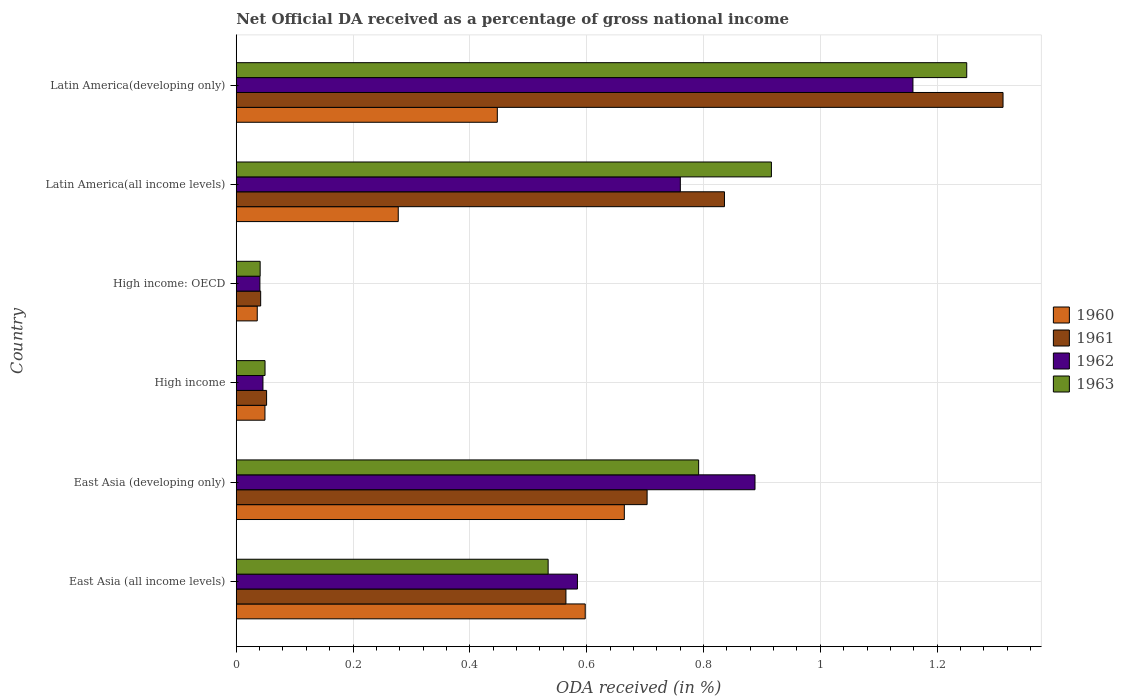How many different coloured bars are there?
Provide a succinct answer. 4. How many groups of bars are there?
Keep it short and to the point. 6. Are the number of bars on each tick of the Y-axis equal?
Offer a terse response. Yes. How many bars are there on the 3rd tick from the top?
Ensure brevity in your answer.  4. How many bars are there on the 4th tick from the bottom?
Keep it short and to the point. 4. What is the label of the 3rd group of bars from the top?
Provide a succinct answer. High income: OECD. What is the net official DA received in 1960 in High income: OECD?
Provide a short and direct response. 0.04. Across all countries, what is the maximum net official DA received in 1961?
Give a very brief answer. 1.31. Across all countries, what is the minimum net official DA received in 1961?
Provide a short and direct response. 0.04. In which country was the net official DA received in 1960 maximum?
Make the answer very short. East Asia (developing only). In which country was the net official DA received in 1961 minimum?
Your answer should be very brief. High income: OECD. What is the total net official DA received in 1962 in the graph?
Provide a short and direct response. 3.48. What is the difference between the net official DA received in 1962 in High income: OECD and that in Latin America(all income levels)?
Your response must be concise. -0.72. What is the difference between the net official DA received in 1960 in Latin America(developing only) and the net official DA received in 1962 in High income: OECD?
Ensure brevity in your answer.  0.41. What is the average net official DA received in 1962 per country?
Give a very brief answer. 0.58. What is the difference between the net official DA received in 1960 and net official DA received in 1961 in East Asia (all income levels)?
Keep it short and to the point. 0.03. In how many countries, is the net official DA received in 1960 greater than 1.12 %?
Make the answer very short. 0. What is the ratio of the net official DA received in 1961 in Latin America(all income levels) to that in Latin America(developing only)?
Make the answer very short. 0.64. Is the net official DA received in 1963 in East Asia (developing only) less than that in Latin America(developing only)?
Your response must be concise. Yes. What is the difference between the highest and the second highest net official DA received in 1961?
Your response must be concise. 0.48. What is the difference between the highest and the lowest net official DA received in 1961?
Provide a short and direct response. 1.27. In how many countries, is the net official DA received in 1962 greater than the average net official DA received in 1962 taken over all countries?
Provide a succinct answer. 4. Is it the case that in every country, the sum of the net official DA received in 1961 and net official DA received in 1962 is greater than the sum of net official DA received in 1963 and net official DA received in 1960?
Give a very brief answer. No. What does the 3rd bar from the top in East Asia (all income levels) represents?
Offer a very short reply. 1961. What does the 2nd bar from the bottom in Latin America(all income levels) represents?
Offer a terse response. 1961. How many bars are there?
Keep it short and to the point. 24. Are the values on the major ticks of X-axis written in scientific E-notation?
Offer a terse response. No. Where does the legend appear in the graph?
Provide a short and direct response. Center right. How many legend labels are there?
Offer a terse response. 4. What is the title of the graph?
Provide a succinct answer. Net Official DA received as a percentage of gross national income. What is the label or title of the X-axis?
Offer a very short reply. ODA received (in %). What is the label or title of the Y-axis?
Your answer should be compact. Country. What is the ODA received (in %) of 1960 in East Asia (all income levels)?
Provide a short and direct response. 0.6. What is the ODA received (in %) in 1961 in East Asia (all income levels)?
Make the answer very short. 0.56. What is the ODA received (in %) of 1962 in East Asia (all income levels)?
Provide a succinct answer. 0.58. What is the ODA received (in %) of 1963 in East Asia (all income levels)?
Your answer should be very brief. 0.53. What is the ODA received (in %) of 1960 in East Asia (developing only)?
Your answer should be very brief. 0.66. What is the ODA received (in %) of 1961 in East Asia (developing only)?
Your response must be concise. 0.7. What is the ODA received (in %) of 1962 in East Asia (developing only)?
Your response must be concise. 0.89. What is the ODA received (in %) in 1963 in East Asia (developing only)?
Ensure brevity in your answer.  0.79. What is the ODA received (in %) of 1960 in High income?
Your answer should be compact. 0.05. What is the ODA received (in %) of 1961 in High income?
Provide a short and direct response. 0.05. What is the ODA received (in %) in 1962 in High income?
Keep it short and to the point. 0.05. What is the ODA received (in %) in 1963 in High income?
Provide a succinct answer. 0.05. What is the ODA received (in %) in 1960 in High income: OECD?
Offer a very short reply. 0.04. What is the ODA received (in %) in 1961 in High income: OECD?
Keep it short and to the point. 0.04. What is the ODA received (in %) in 1962 in High income: OECD?
Make the answer very short. 0.04. What is the ODA received (in %) in 1963 in High income: OECD?
Keep it short and to the point. 0.04. What is the ODA received (in %) in 1960 in Latin America(all income levels)?
Offer a very short reply. 0.28. What is the ODA received (in %) of 1961 in Latin America(all income levels)?
Keep it short and to the point. 0.84. What is the ODA received (in %) of 1962 in Latin America(all income levels)?
Provide a succinct answer. 0.76. What is the ODA received (in %) of 1963 in Latin America(all income levels)?
Your answer should be very brief. 0.92. What is the ODA received (in %) of 1960 in Latin America(developing only)?
Provide a short and direct response. 0.45. What is the ODA received (in %) in 1961 in Latin America(developing only)?
Your answer should be very brief. 1.31. What is the ODA received (in %) in 1962 in Latin America(developing only)?
Keep it short and to the point. 1.16. What is the ODA received (in %) of 1963 in Latin America(developing only)?
Provide a short and direct response. 1.25. Across all countries, what is the maximum ODA received (in %) of 1960?
Provide a succinct answer. 0.66. Across all countries, what is the maximum ODA received (in %) of 1961?
Your response must be concise. 1.31. Across all countries, what is the maximum ODA received (in %) in 1962?
Give a very brief answer. 1.16. Across all countries, what is the maximum ODA received (in %) in 1963?
Keep it short and to the point. 1.25. Across all countries, what is the minimum ODA received (in %) in 1960?
Offer a very short reply. 0.04. Across all countries, what is the minimum ODA received (in %) of 1961?
Give a very brief answer. 0.04. Across all countries, what is the minimum ODA received (in %) of 1962?
Ensure brevity in your answer.  0.04. Across all countries, what is the minimum ODA received (in %) of 1963?
Make the answer very short. 0.04. What is the total ODA received (in %) of 1960 in the graph?
Your answer should be very brief. 2.07. What is the total ODA received (in %) of 1961 in the graph?
Give a very brief answer. 3.51. What is the total ODA received (in %) in 1962 in the graph?
Ensure brevity in your answer.  3.48. What is the total ODA received (in %) of 1963 in the graph?
Ensure brevity in your answer.  3.58. What is the difference between the ODA received (in %) of 1960 in East Asia (all income levels) and that in East Asia (developing only)?
Ensure brevity in your answer.  -0.07. What is the difference between the ODA received (in %) in 1961 in East Asia (all income levels) and that in East Asia (developing only)?
Give a very brief answer. -0.14. What is the difference between the ODA received (in %) of 1962 in East Asia (all income levels) and that in East Asia (developing only)?
Keep it short and to the point. -0.3. What is the difference between the ODA received (in %) of 1963 in East Asia (all income levels) and that in East Asia (developing only)?
Keep it short and to the point. -0.26. What is the difference between the ODA received (in %) of 1960 in East Asia (all income levels) and that in High income?
Provide a short and direct response. 0.55. What is the difference between the ODA received (in %) in 1961 in East Asia (all income levels) and that in High income?
Ensure brevity in your answer.  0.51. What is the difference between the ODA received (in %) of 1962 in East Asia (all income levels) and that in High income?
Ensure brevity in your answer.  0.54. What is the difference between the ODA received (in %) of 1963 in East Asia (all income levels) and that in High income?
Give a very brief answer. 0.48. What is the difference between the ODA received (in %) of 1960 in East Asia (all income levels) and that in High income: OECD?
Provide a short and direct response. 0.56. What is the difference between the ODA received (in %) of 1961 in East Asia (all income levels) and that in High income: OECD?
Make the answer very short. 0.52. What is the difference between the ODA received (in %) in 1962 in East Asia (all income levels) and that in High income: OECD?
Ensure brevity in your answer.  0.54. What is the difference between the ODA received (in %) in 1963 in East Asia (all income levels) and that in High income: OECD?
Offer a very short reply. 0.49. What is the difference between the ODA received (in %) of 1960 in East Asia (all income levels) and that in Latin America(all income levels)?
Your response must be concise. 0.32. What is the difference between the ODA received (in %) in 1961 in East Asia (all income levels) and that in Latin America(all income levels)?
Provide a succinct answer. -0.27. What is the difference between the ODA received (in %) in 1962 in East Asia (all income levels) and that in Latin America(all income levels)?
Provide a short and direct response. -0.18. What is the difference between the ODA received (in %) of 1963 in East Asia (all income levels) and that in Latin America(all income levels)?
Offer a terse response. -0.38. What is the difference between the ODA received (in %) of 1960 in East Asia (all income levels) and that in Latin America(developing only)?
Offer a terse response. 0.15. What is the difference between the ODA received (in %) in 1961 in East Asia (all income levels) and that in Latin America(developing only)?
Ensure brevity in your answer.  -0.75. What is the difference between the ODA received (in %) of 1962 in East Asia (all income levels) and that in Latin America(developing only)?
Your response must be concise. -0.57. What is the difference between the ODA received (in %) of 1963 in East Asia (all income levels) and that in Latin America(developing only)?
Your response must be concise. -0.72. What is the difference between the ODA received (in %) of 1960 in East Asia (developing only) and that in High income?
Offer a very short reply. 0.62. What is the difference between the ODA received (in %) in 1961 in East Asia (developing only) and that in High income?
Provide a short and direct response. 0.65. What is the difference between the ODA received (in %) in 1962 in East Asia (developing only) and that in High income?
Ensure brevity in your answer.  0.84. What is the difference between the ODA received (in %) in 1963 in East Asia (developing only) and that in High income?
Ensure brevity in your answer.  0.74. What is the difference between the ODA received (in %) of 1960 in East Asia (developing only) and that in High income: OECD?
Offer a terse response. 0.63. What is the difference between the ODA received (in %) in 1961 in East Asia (developing only) and that in High income: OECD?
Give a very brief answer. 0.66. What is the difference between the ODA received (in %) in 1962 in East Asia (developing only) and that in High income: OECD?
Provide a succinct answer. 0.85. What is the difference between the ODA received (in %) in 1963 in East Asia (developing only) and that in High income: OECD?
Your response must be concise. 0.75. What is the difference between the ODA received (in %) in 1960 in East Asia (developing only) and that in Latin America(all income levels)?
Provide a succinct answer. 0.39. What is the difference between the ODA received (in %) of 1961 in East Asia (developing only) and that in Latin America(all income levels)?
Your answer should be compact. -0.13. What is the difference between the ODA received (in %) of 1962 in East Asia (developing only) and that in Latin America(all income levels)?
Your response must be concise. 0.13. What is the difference between the ODA received (in %) of 1963 in East Asia (developing only) and that in Latin America(all income levels)?
Provide a short and direct response. -0.12. What is the difference between the ODA received (in %) of 1960 in East Asia (developing only) and that in Latin America(developing only)?
Your answer should be compact. 0.22. What is the difference between the ODA received (in %) of 1961 in East Asia (developing only) and that in Latin America(developing only)?
Your response must be concise. -0.61. What is the difference between the ODA received (in %) of 1962 in East Asia (developing only) and that in Latin America(developing only)?
Make the answer very short. -0.27. What is the difference between the ODA received (in %) of 1963 in East Asia (developing only) and that in Latin America(developing only)?
Offer a terse response. -0.46. What is the difference between the ODA received (in %) in 1960 in High income and that in High income: OECD?
Ensure brevity in your answer.  0.01. What is the difference between the ODA received (in %) of 1961 in High income and that in High income: OECD?
Offer a very short reply. 0.01. What is the difference between the ODA received (in %) of 1962 in High income and that in High income: OECD?
Offer a terse response. 0.01. What is the difference between the ODA received (in %) in 1963 in High income and that in High income: OECD?
Offer a very short reply. 0.01. What is the difference between the ODA received (in %) of 1960 in High income and that in Latin America(all income levels)?
Give a very brief answer. -0.23. What is the difference between the ODA received (in %) in 1961 in High income and that in Latin America(all income levels)?
Give a very brief answer. -0.78. What is the difference between the ODA received (in %) in 1962 in High income and that in Latin America(all income levels)?
Your answer should be very brief. -0.71. What is the difference between the ODA received (in %) in 1963 in High income and that in Latin America(all income levels)?
Make the answer very short. -0.87. What is the difference between the ODA received (in %) of 1960 in High income and that in Latin America(developing only)?
Keep it short and to the point. -0.4. What is the difference between the ODA received (in %) of 1961 in High income and that in Latin America(developing only)?
Make the answer very short. -1.26. What is the difference between the ODA received (in %) of 1962 in High income and that in Latin America(developing only)?
Ensure brevity in your answer.  -1.11. What is the difference between the ODA received (in %) in 1963 in High income and that in Latin America(developing only)?
Offer a terse response. -1.2. What is the difference between the ODA received (in %) of 1960 in High income: OECD and that in Latin America(all income levels)?
Provide a short and direct response. -0.24. What is the difference between the ODA received (in %) in 1961 in High income: OECD and that in Latin America(all income levels)?
Ensure brevity in your answer.  -0.79. What is the difference between the ODA received (in %) in 1962 in High income: OECD and that in Latin America(all income levels)?
Offer a terse response. -0.72. What is the difference between the ODA received (in %) of 1963 in High income: OECD and that in Latin America(all income levels)?
Provide a short and direct response. -0.88. What is the difference between the ODA received (in %) of 1960 in High income: OECD and that in Latin America(developing only)?
Make the answer very short. -0.41. What is the difference between the ODA received (in %) in 1961 in High income: OECD and that in Latin America(developing only)?
Keep it short and to the point. -1.27. What is the difference between the ODA received (in %) of 1962 in High income: OECD and that in Latin America(developing only)?
Your answer should be very brief. -1.12. What is the difference between the ODA received (in %) of 1963 in High income: OECD and that in Latin America(developing only)?
Make the answer very short. -1.21. What is the difference between the ODA received (in %) of 1960 in Latin America(all income levels) and that in Latin America(developing only)?
Provide a short and direct response. -0.17. What is the difference between the ODA received (in %) of 1961 in Latin America(all income levels) and that in Latin America(developing only)?
Give a very brief answer. -0.48. What is the difference between the ODA received (in %) in 1962 in Latin America(all income levels) and that in Latin America(developing only)?
Offer a very short reply. -0.4. What is the difference between the ODA received (in %) of 1963 in Latin America(all income levels) and that in Latin America(developing only)?
Give a very brief answer. -0.33. What is the difference between the ODA received (in %) in 1960 in East Asia (all income levels) and the ODA received (in %) in 1961 in East Asia (developing only)?
Your answer should be very brief. -0.11. What is the difference between the ODA received (in %) of 1960 in East Asia (all income levels) and the ODA received (in %) of 1962 in East Asia (developing only)?
Give a very brief answer. -0.29. What is the difference between the ODA received (in %) of 1960 in East Asia (all income levels) and the ODA received (in %) of 1963 in East Asia (developing only)?
Your answer should be compact. -0.19. What is the difference between the ODA received (in %) in 1961 in East Asia (all income levels) and the ODA received (in %) in 1962 in East Asia (developing only)?
Keep it short and to the point. -0.32. What is the difference between the ODA received (in %) of 1961 in East Asia (all income levels) and the ODA received (in %) of 1963 in East Asia (developing only)?
Keep it short and to the point. -0.23. What is the difference between the ODA received (in %) of 1962 in East Asia (all income levels) and the ODA received (in %) of 1963 in East Asia (developing only)?
Provide a short and direct response. -0.21. What is the difference between the ODA received (in %) of 1960 in East Asia (all income levels) and the ODA received (in %) of 1961 in High income?
Give a very brief answer. 0.55. What is the difference between the ODA received (in %) in 1960 in East Asia (all income levels) and the ODA received (in %) in 1962 in High income?
Your answer should be compact. 0.55. What is the difference between the ODA received (in %) in 1960 in East Asia (all income levels) and the ODA received (in %) in 1963 in High income?
Provide a succinct answer. 0.55. What is the difference between the ODA received (in %) of 1961 in East Asia (all income levels) and the ODA received (in %) of 1962 in High income?
Make the answer very short. 0.52. What is the difference between the ODA received (in %) in 1961 in East Asia (all income levels) and the ODA received (in %) in 1963 in High income?
Ensure brevity in your answer.  0.52. What is the difference between the ODA received (in %) of 1962 in East Asia (all income levels) and the ODA received (in %) of 1963 in High income?
Offer a very short reply. 0.53. What is the difference between the ODA received (in %) of 1960 in East Asia (all income levels) and the ODA received (in %) of 1961 in High income: OECD?
Give a very brief answer. 0.56. What is the difference between the ODA received (in %) in 1960 in East Asia (all income levels) and the ODA received (in %) in 1962 in High income: OECD?
Provide a succinct answer. 0.56. What is the difference between the ODA received (in %) in 1960 in East Asia (all income levels) and the ODA received (in %) in 1963 in High income: OECD?
Provide a succinct answer. 0.56. What is the difference between the ODA received (in %) in 1961 in East Asia (all income levels) and the ODA received (in %) in 1962 in High income: OECD?
Provide a short and direct response. 0.52. What is the difference between the ODA received (in %) in 1961 in East Asia (all income levels) and the ODA received (in %) in 1963 in High income: OECD?
Ensure brevity in your answer.  0.52. What is the difference between the ODA received (in %) in 1962 in East Asia (all income levels) and the ODA received (in %) in 1963 in High income: OECD?
Keep it short and to the point. 0.54. What is the difference between the ODA received (in %) in 1960 in East Asia (all income levels) and the ODA received (in %) in 1961 in Latin America(all income levels)?
Ensure brevity in your answer.  -0.24. What is the difference between the ODA received (in %) of 1960 in East Asia (all income levels) and the ODA received (in %) of 1962 in Latin America(all income levels)?
Make the answer very short. -0.16. What is the difference between the ODA received (in %) in 1960 in East Asia (all income levels) and the ODA received (in %) in 1963 in Latin America(all income levels)?
Provide a short and direct response. -0.32. What is the difference between the ODA received (in %) of 1961 in East Asia (all income levels) and the ODA received (in %) of 1962 in Latin America(all income levels)?
Your response must be concise. -0.2. What is the difference between the ODA received (in %) in 1961 in East Asia (all income levels) and the ODA received (in %) in 1963 in Latin America(all income levels)?
Your response must be concise. -0.35. What is the difference between the ODA received (in %) of 1962 in East Asia (all income levels) and the ODA received (in %) of 1963 in Latin America(all income levels)?
Ensure brevity in your answer.  -0.33. What is the difference between the ODA received (in %) in 1960 in East Asia (all income levels) and the ODA received (in %) in 1961 in Latin America(developing only)?
Provide a succinct answer. -0.72. What is the difference between the ODA received (in %) in 1960 in East Asia (all income levels) and the ODA received (in %) in 1962 in Latin America(developing only)?
Keep it short and to the point. -0.56. What is the difference between the ODA received (in %) of 1960 in East Asia (all income levels) and the ODA received (in %) of 1963 in Latin America(developing only)?
Your response must be concise. -0.65. What is the difference between the ODA received (in %) in 1961 in East Asia (all income levels) and the ODA received (in %) in 1962 in Latin America(developing only)?
Your response must be concise. -0.59. What is the difference between the ODA received (in %) of 1961 in East Asia (all income levels) and the ODA received (in %) of 1963 in Latin America(developing only)?
Ensure brevity in your answer.  -0.69. What is the difference between the ODA received (in %) of 1962 in East Asia (all income levels) and the ODA received (in %) of 1963 in Latin America(developing only)?
Your response must be concise. -0.67. What is the difference between the ODA received (in %) in 1960 in East Asia (developing only) and the ODA received (in %) in 1961 in High income?
Offer a very short reply. 0.61. What is the difference between the ODA received (in %) in 1960 in East Asia (developing only) and the ODA received (in %) in 1962 in High income?
Provide a short and direct response. 0.62. What is the difference between the ODA received (in %) of 1960 in East Asia (developing only) and the ODA received (in %) of 1963 in High income?
Your answer should be very brief. 0.62. What is the difference between the ODA received (in %) in 1961 in East Asia (developing only) and the ODA received (in %) in 1962 in High income?
Give a very brief answer. 0.66. What is the difference between the ODA received (in %) of 1961 in East Asia (developing only) and the ODA received (in %) of 1963 in High income?
Ensure brevity in your answer.  0.65. What is the difference between the ODA received (in %) of 1962 in East Asia (developing only) and the ODA received (in %) of 1963 in High income?
Offer a terse response. 0.84. What is the difference between the ODA received (in %) in 1960 in East Asia (developing only) and the ODA received (in %) in 1961 in High income: OECD?
Offer a terse response. 0.62. What is the difference between the ODA received (in %) of 1960 in East Asia (developing only) and the ODA received (in %) of 1962 in High income: OECD?
Provide a succinct answer. 0.62. What is the difference between the ODA received (in %) of 1960 in East Asia (developing only) and the ODA received (in %) of 1963 in High income: OECD?
Ensure brevity in your answer.  0.62. What is the difference between the ODA received (in %) of 1961 in East Asia (developing only) and the ODA received (in %) of 1962 in High income: OECD?
Your answer should be very brief. 0.66. What is the difference between the ODA received (in %) of 1961 in East Asia (developing only) and the ODA received (in %) of 1963 in High income: OECD?
Keep it short and to the point. 0.66. What is the difference between the ODA received (in %) of 1962 in East Asia (developing only) and the ODA received (in %) of 1963 in High income: OECD?
Provide a succinct answer. 0.85. What is the difference between the ODA received (in %) in 1960 in East Asia (developing only) and the ODA received (in %) in 1961 in Latin America(all income levels)?
Provide a succinct answer. -0.17. What is the difference between the ODA received (in %) in 1960 in East Asia (developing only) and the ODA received (in %) in 1962 in Latin America(all income levels)?
Ensure brevity in your answer.  -0.1. What is the difference between the ODA received (in %) in 1960 in East Asia (developing only) and the ODA received (in %) in 1963 in Latin America(all income levels)?
Your response must be concise. -0.25. What is the difference between the ODA received (in %) of 1961 in East Asia (developing only) and the ODA received (in %) of 1962 in Latin America(all income levels)?
Ensure brevity in your answer.  -0.06. What is the difference between the ODA received (in %) in 1961 in East Asia (developing only) and the ODA received (in %) in 1963 in Latin America(all income levels)?
Provide a short and direct response. -0.21. What is the difference between the ODA received (in %) of 1962 in East Asia (developing only) and the ODA received (in %) of 1963 in Latin America(all income levels)?
Offer a terse response. -0.03. What is the difference between the ODA received (in %) of 1960 in East Asia (developing only) and the ODA received (in %) of 1961 in Latin America(developing only)?
Make the answer very short. -0.65. What is the difference between the ODA received (in %) of 1960 in East Asia (developing only) and the ODA received (in %) of 1962 in Latin America(developing only)?
Your answer should be compact. -0.49. What is the difference between the ODA received (in %) of 1960 in East Asia (developing only) and the ODA received (in %) of 1963 in Latin America(developing only)?
Offer a very short reply. -0.59. What is the difference between the ODA received (in %) of 1961 in East Asia (developing only) and the ODA received (in %) of 1962 in Latin America(developing only)?
Provide a succinct answer. -0.46. What is the difference between the ODA received (in %) in 1961 in East Asia (developing only) and the ODA received (in %) in 1963 in Latin America(developing only)?
Provide a succinct answer. -0.55. What is the difference between the ODA received (in %) of 1962 in East Asia (developing only) and the ODA received (in %) of 1963 in Latin America(developing only)?
Your answer should be compact. -0.36. What is the difference between the ODA received (in %) of 1960 in High income and the ODA received (in %) of 1961 in High income: OECD?
Your response must be concise. 0.01. What is the difference between the ODA received (in %) in 1960 in High income and the ODA received (in %) in 1962 in High income: OECD?
Provide a short and direct response. 0.01. What is the difference between the ODA received (in %) of 1960 in High income and the ODA received (in %) of 1963 in High income: OECD?
Ensure brevity in your answer.  0.01. What is the difference between the ODA received (in %) in 1961 in High income and the ODA received (in %) in 1962 in High income: OECD?
Your response must be concise. 0.01. What is the difference between the ODA received (in %) of 1961 in High income and the ODA received (in %) of 1963 in High income: OECD?
Offer a terse response. 0.01. What is the difference between the ODA received (in %) in 1962 in High income and the ODA received (in %) in 1963 in High income: OECD?
Keep it short and to the point. 0. What is the difference between the ODA received (in %) of 1960 in High income and the ODA received (in %) of 1961 in Latin America(all income levels)?
Provide a short and direct response. -0.79. What is the difference between the ODA received (in %) in 1960 in High income and the ODA received (in %) in 1962 in Latin America(all income levels)?
Keep it short and to the point. -0.71. What is the difference between the ODA received (in %) of 1960 in High income and the ODA received (in %) of 1963 in Latin America(all income levels)?
Provide a succinct answer. -0.87. What is the difference between the ODA received (in %) of 1961 in High income and the ODA received (in %) of 1962 in Latin America(all income levels)?
Provide a succinct answer. -0.71. What is the difference between the ODA received (in %) of 1961 in High income and the ODA received (in %) of 1963 in Latin America(all income levels)?
Your answer should be compact. -0.86. What is the difference between the ODA received (in %) in 1962 in High income and the ODA received (in %) in 1963 in Latin America(all income levels)?
Your answer should be compact. -0.87. What is the difference between the ODA received (in %) in 1960 in High income and the ODA received (in %) in 1961 in Latin America(developing only)?
Your answer should be very brief. -1.26. What is the difference between the ODA received (in %) of 1960 in High income and the ODA received (in %) of 1962 in Latin America(developing only)?
Your response must be concise. -1.11. What is the difference between the ODA received (in %) in 1960 in High income and the ODA received (in %) in 1963 in Latin America(developing only)?
Ensure brevity in your answer.  -1.2. What is the difference between the ODA received (in %) of 1961 in High income and the ODA received (in %) of 1962 in Latin America(developing only)?
Offer a terse response. -1.11. What is the difference between the ODA received (in %) of 1961 in High income and the ODA received (in %) of 1963 in Latin America(developing only)?
Keep it short and to the point. -1.2. What is the difference between the ODA received (in %) in 1962 in High income and the ODA received (in %) in 1963 in Latin America(developing only)?
Offer a very short reply. -1.2. What is the difference between the ODA received (in %) of 1960 in High income: OECD and the ODA received (in %) of 1961 in Latin America(all income levels)?
Ensure brevity in your answer.  -0.8. What is the difference between the ODA received (in %) in 1960 in High income: OECD and the ODA received (in %) in 1962 in Latin America(all income levels)?
Your answer should be very brief. -0.72. What is the difference between the ODA received (in %) of 1960 in High income: OECD and the ODA received (in %) of 1963 in Latin America(all income levels)?
Keep it short and to the point. -0.88. What is the difference between the ODA received (in %) of 1961 in High income: OECD and the ODA received (in %) of 1962 in Latin America(all income levels)?
Offer a terse response. -0.72. What is the difference between the ODA received (in %) in 1961 in High income: OECD and the ODA received (in %) in 1963 in Latin America(all income levels)?
Your answer should be very brief. -0.87. What is the difference between the ODA received (in %) of 1962 in High income: OECD and the ODA received (in %) of 1963 in Latin America(all income levels)?
Offer a very short reply. -0.88. What is the difference between the ODA received (in %) of 1960 in High income: OECD and the ODA received (in %) of 1961 in Latin America(developing only)?
Your answer should be very brief. -1.28. What is the difference between the ODA received (in %) of 1960 in High income: OECD and the ODA received (in %) of 1962 in Latin America(developing only)?
Provide a short and direct response. -1.12. What is the difference between the ODA received (in %) of 1960 in High income: OECD and the ODA received (in %) of 1963 in Latin America(developing only)?
Provide a succinct answer. -1.21. What is the difference between the ODA received (in %) in 1961 in High income: OECD and the ODA received (in %) in 1962 in Latin America(developing only)?
Your answer should be very brief. -1.12. What is the difference between the ODA received (in %) of 1961 in High income: OECD and the ODA received (in %) of 1963 in Latin America(developing only)?
Offer a very short reply. -1.21. What is the difference between the ODA received (in %) of 1962 in High income: OECD and the ODA received (in %) of 1963 in Latin America(developing only)?
Make the answer very short. -1.21. What is the difference between the ODA received (in %) in 1960 in Latin America(all income levels) and the ODA received (in %) in 1961 in Latin America(developing only)?
Offer a very short reply. -1.04. What is the difference between the ODA received (in %) in 1960 in Latin America(all income levels) and the ODA received (in %) in 1962 in Latin America(developing only)?
Provide a succinct answer. -0.88. What is the difference between the ODA received (in %) of 1960 in Latin America(all income levels) and the ODA received (in %) of 1963 in Latin America(developing only)?
Your answer should be compact. -0.97. What is the difference between the ODA received (in %) in 1961 in Latin America(all income levels) and the ODA received (in %) in 1962 in Latin America(developing only)?
Give a very brief answer. -0.32. What is the difference between the ODA received (in %) in 1961 in Latin America(all income levels) and the ODA received (in %) in 1963 in Latin America(developing only)?
Ensure brevity in your answer.  -0.41. What is the difference between the ODA received (in %) in 1962 in Latin America(all income levels) and the ODA received (in %) in 1963 in Latin America(developing only)?
Offer a very short reply. -0.49. What is the average ODA received (in %) in 1960 per country?
Offer a terse response. 0.35. What is the average ODA received (in %) of 1961 per country?
Give a very brief answer. 0.58. What is the average ODA received (in %) of 1962 per country?
Offer a terse response. 0.58. What is the average ODA received (in %) of 1963 per country?
Ensure brevity in your answer.  0.6. What is the difference between the ODA received (in %) of 1960 and ODA received (in %) of 1961 in East Asia (all income levels)?
Your answer should be very brief. 0.03. What is the difference between the ODA received (in %) of 1960 and ODA received (in %) of 1962 in East Asia (all income levels)?
Provide a succinct answer. 0.01. What is the difference between the ODA received (in %) in 1960 and ODA received (in %) in 1963 in East Asia (all income levels)?
Give a very brief answer. 0.06. What is the difference between the ODA received (in %) in 1961 and ODA received (in %) in 1962 in East Asia (all income levels)?
Ensure brevity in your answer.  -0.02. What is the difference between the ODA received (in %) in 1961 and ODA received (in %) in 1963 in East Asia (all income levels)?
Make the answer very short. 0.03. What is the difference between the ODA received (in %) in 1962 and ODA received (in %) in 1963 in East Asia (all income levels)?
Offer a very short reply. 0.05. What is the difference between the ODA received (in %) in 1960 and ODA received (in %) in 1961 in East Asia (developing only)?
Offer a very short reply. -0.04. What is the difference between the ODA received (in %) in 1960 and ODA received (in %) in 1962 in East Asia (developing only)?
Provide a succinct answer. -0.22. What is the difference between the ODA received (in %) in 1960 and ODA received (in %) in 1963 in East Asia (developing only)?
Ensure brevity in your answer.  -0.13. What is the difference between the ODA received (in %) of 1961 and ODA received (in %) of 1962 in East Asia (developing only)?
Make the answer very short. -0.18. What is the difference between the ODA received (in %) in 1961 and ODA received (in %) in 1963 in East Asia (developing only)?
Make the answer very short. -0.09. What is the difference between the ODA received (in %) of 1962 and ODA received (in %) of 1963 in East Asia (developing only)?
Your response must be concise. 0.1. What is the difference between the ODA received (in %) in 1960 and ODA received (in %) in 1961 in High income?
Give a very brief answer. -0. What is the difference between the ODA received (in %) in 1960 and ODA received (in %) in 1962 in High income?
Offer a terse response. 0. What is the difference between the ODA received (in %) in 1960 and ODA received (in %) in 1963 in High income?
Provide a succinct answer. -0. What is the difference between the ODA received (in %) in 1961 and ODA received (in %) in 1962 in High income?
Your answer should be very brief. 0.01. What is the difference between the ODA received (in %) in 1961 and ODA received (in %) in 1963 in High income?
Keep it short and to the point. 0. What is the difference between the ODA received (in %) of 1962 and ODA received (in %) of 1963 in High income?
Offer a very short reply. -0. What is the difference between the ODA received (in %) of 1960 and ODA received (in %) of 1961 in High income: OECD?
Give a very brief answer. -0.01. What is the difference between the ODA received (in %) of 1960 and ODA received (in %) of 1962 in High income: OECD?
Give a very brief answer. -0. What is the difference between the ODA received (in %) of 1960 and ODA received (in %) of 1963 in High income: OECD?
Offer a terse response. -0.01. What is the difference between the ODA received (in %) of 1961 and ODA received (in %) of 1962 in High income: OECD?
Your response must be concise. 0. What is the difference between the ODA received (in %) of 1961 and ODA received (in %) of 1963 in High income: OECD?
Your response must be concise. 0. What is the difference between the ODA received (in %) of 1962 and ODA received (in %) of 1963 in High income: OECD?
Offer a very short reply. -0. What is the difference between the ODA received (in %) in 1960 and ODA received (in %) in 1961 in Latin America(all income levels)?
Offer a terse response. -0.56. What is the difference between the ODA received (in %) in 1960 and ODA received (in %) in 1962 in Latin America(all income levels)?
Your response must be concise. -0.48. What is the difference between the ODA received (in %) in 1960 and ODA received (in %) in 1963 in Latin America(all income levels)?
Your response must be concise. -0.64. What is the difference between the ODA received (in %) in 1961 and ODA received (in %) in 1962 in Latin America(all income levels)?
Provide a short and direct response. 0.08. What is the difference between the ODA received (in %) in 1961 and ODA received (in %) in 1963 in Latin America(all income levels)?
Offer a terse response. -0.08. What is the difference between the ODA received (in %) of 1962 and ODA received (in %) of 1963 in Latin America(all income levels)?
Provide a succinct answer. -0.16. What is the difference between the ODA received (in %) of 1960 and ODA received (in %) of 1961 in Latin America(developing only)?
Offer a very short reply. -0.87. What is the difference between the ODA received (in %) in 1960 and ODA received (in %) in 1962 in Latin America(developing only)?
Your answer should be compact. -0.71. What is the difference between the ODA received (in %) of 1960 and ODA received (in %) of 1963 in Latin America(developing only)?
Provide a succinct answer. -0.8. What is the difference between the ODA received (in %) of 1961 and ODA received (in %) of 1962 in Latin America(developing only)?
Your answer should be compact. 0.15. What is the difference between the ODA received (in %) of 1961 and ODA received (in %) of 1963 in Latin America(developing only)?
Ensure brevity in your answer.  0.06. What is the difference between the ODA received (in %) of 1962 and ODA received (in %) of 1963 in Latin America(developing only)?
Offer a terse response. -0.09. What is the ratio of the ODA received (in %) in 1960 in East Asia (all income levels) to that in East Asia (developing only)?
Your answer should be compact. 0.9. What is the ratio of the ODA received (in %) in 1961 in East Asia (all income levels) to that in East Asia (developing only)?
Provide a succinct answer. 0.8. What is the ratio of the ODA received (in %) of 1962 in East Asia (all income levels) to that in East Asia (developing only)?
Provide a succinct answer. 0.66. What is the ratio of the ODA received (in %) of 1963 in East Asia (all income levels) to that in East Asia (developing only)?
Your answer should be very brief. 0.67. What is the ratio of the ODA received (in %) of 1960 in East Asia (all income levels) to that in High income?
Your answer should be very brief. 12.16. What is the ratio of the ODA received (in %) in 1961 in East Asia (all income levels) to that in High income?
Ensure brevity in your answer.  10.87. What is the ratio of the ODA received (in %) in 1962 in East Asia (all income levels) to that in High income?
Keep it short and to the point. 12.78. What is the ratio of the ODA received (in %) in 1963 in East Asia (all income levels) to that in High income?
Keep it short and to the point. 10.84. What is the ratio of the ODA received (in %) in 1960 in East Asia (all income levels) to that in High income: OECD?
Your response must be concise. 16.62. What is the ratio of the ODA received (in %) of 1961 in East Asia (all income levels) to that in High income: OECD?
Keep it short and to the point. 13.5. What is the ratio of the ODA received (in %) of 1962 in East Asia (all income levels) to that in High income: OECD?
Offer a very short reply. 14.43. What is the ratio of the ODA received (in %) in 1963 in East Asia (all income levels) to that in High income: OECD?
Offer a terse response. 13.05. What is the ratio of the ODA received (in %) in 1960 in East Asia (all income levels) to that in Latin America(all income levels)?
Offer a terse response. 2.15. What is the ratio of the ODA received (in %) in 1961 in East Asia (all income levels) to that in Latin America(all income levels)?
Provide a succinct answer. 0.68. What is the ratio of the ODA received (in %) in 1962 in East Asia (all income levels) to that in Latin America(all income levels)?
Ensure brevity in your answer.  0.77. What is the ratio of the ODA received (in %) of 1963 in East Asia (all income levels) to that in Latin America(all income levels)?
Provide a short and direct response. 0.58. What is the ratio of the ODA received (in %) in 1960 in East Asia (all income levels) to that in Latin America(developing only)?
Your response must be concise. 1.34. What is the ratio of the ODA received (in %) in 1961 in East Asia (all income levels) to that in Latin America(developing only)?
Offer a very short reply. 0.43. What is the ratio of the ODA received (in %) in 1962 in East Asia (all income levels) to that in Latin America(developing only)?
Provide a succinct answer. 0.5. What is the ratio of the ODA received (in %) in 1963 in East Asia (all income levels) to that in Latin America(developing only)?
Your answer should be compact. 0.43. What is the ratio of the ODA received (in %) of 1960 in East Asia (developing only) to that in High income?
Give a very brief answer. 13.52. What is the ratio of the ODA received (in %) of 1961 in East Asia (developing only) to that in High income?
Your answer should be very brief. 13.54. What is the ratio of the ODA received (in %) of 1962 in East Asia (developing only) to that in High income?
Offer a terse response. 19.42. What is the ratio of the ODA received (in %) of 1963 in East Asia (developing only) to that in High income?
Your answer should be very brief. 16.07. What is the ratio of the ODA received (in %) of 1960 in East Asia (developing only) to that in High income: OECD?
Your answer should be compact. 18.48. What is the ratio of the ODA received (in %) of 1961 in East Asia (developing only) to that in High income: OECD?
Your response must be concise. 16.83. What is the ratio of the ODA received (in %) in 1962 in East Asia (developing only) to that in High income: OECD?
Keep it short and to the point. 21.93. What is the ratio of the ODA received (in %) in 1963 in East Asia (developing only) to that in High income: OECD?
Provide a succinct answer. 19.34. What is the ratio of the ODA received (in %) in 1960 in East Asia (developing only) to that in Latin America(all income levels)?
Give a very brief answer. 2.4. What is the ratio of the ODA received (in %) in 1961 in East Asia (developing only) to that in Latin America(all income levels)?
Offer a terse response. 0.84. What is the ratio of the ODA received (in %) of 1962 in East Asia (developing only) to that in Latin America(all income levels)?
Give a very brief answer. 1.17. What is the ratio of the ODA received (in %) in 1963 in East Asia (developing only) to that in Latin America(all income levels)?
Give a very brief answer. 0.86. What is the ratio of the ODA received (in %) of 1960 in East Asia (developing only) to that in Latin America(developing only)?
Give a very brief answer. 1.49. What is the ratio of the ODA received (in %) in 1961 in East Asia (developing only) to that in Latin America(developing only)?
Keep it short and to the point. 0.54. What is the ratio of the ODA received (in %) in 1962 in East Asia (developing only) to that in Latin America(developing only)?
Offer a very short reply. 0.77. What is the ratio of the ODA received (in %) in 1963 in East Asia (developing only) to that in Latin America(developing only)?
Give a very brief answer. 0.63. What is the ratio of the ODA received (in %) in 1960 in High income to that in High income: OECD?
Ensure brevity in your answer.  1.37. What is the ratio of the ODA received (in %) in 1961 in High income to that in High income: OECD?
Your answer should be very brief. 1.24. What is the ratio of the ODA received (in %) of 1962 in High income to that in High income: OECD?
Your answer should be very brief. 1.13. What is the ratio of the ODA received (in %) of 1963 in High income to that in High income: OECD?
Your response must be concise. 1.2. What is the ratio of the ODA received (in %) in 1960 in High income to that in Latin America(all income levels)?
Offer a terse response. 0.18. What is the ratio of the ODA received (in %) of 1961 in High income to that in Latin America(all income levels)?
Your answer should be compact. 0.06. What is the ratio of the ODA received (in %) in 1962 in High income to that in Latin America(all income levels)?
Ensure brevity in your answer.  0.06. What is the ratio of the ODA received (in %) in 1963 in High income to that in Latin America(all income levels)?
Provide a short and direct response. 0.05. What is the ratio of the ODA received (in %) in 1960 in High income to that in Latin America(developing only)?
Your response must be concise. 0.11. What is the ratio of the ODA received (in %) of 1961 in High income to that in Latin America(developing only)?
Provide a succinct answer. 0.04. What is the ratio of the ODA received (in %) of 1962 in High income to that in Latin America(developing only)?
Offer a very short reply. 0.04. What is the ratio of the ODA received (in %) in 1963 in High income to that in Latin America(developing only)?
Offer a very short reply. 0.04. What is the ratio of the ODA received (in %) of 1960 in High income: OECD to that in Latin America(all income levels)?
Offer a very short reply. 0.13. What is the ratio of the ODA received (in %) in 1962 in High income: OECD to that in Latin America(all income levels)?
Provide a short and direct response. 0.05. What is the ratio of the ODA received (in %) of 1963 in High income: OECD to that in Latin America(all income levels)?
Your answer should be compact. 0.04. What is the ratio of the ODA received (in %) in 1960 in High income: OECD to that in Latin America(developing only)?
Your answer should be compact. 0.08. What is the ratio of the ODA received (in %) of 1961 in High income: OECD to that in Latin America(developing only)?
Ensure brevity in your answer.  0.03. What is the ratio of the ODA received (in %) of 1962 in High income: OECD to that in Latin America(developing only)?
Offer a terse response. 0.04. What is the ratio of the ODA received (in %) in 1963 in High income: OECD to that in Latin America(developing only)?
Make the answer very short. 0.03. What is the ratio of the ODA received (in %) in 1960 in Latin America(all income levels) to that in Latin America(developing only)?
Give a very brief answer. 0.62. What is the ratio of the ODA received (in %) of 1961 in Latin America(all income levels) to that in Latin America(developing only)?
Provide a short and direct response. 0.64. What is the ratio of the ODA received (in %) in 1962 in Latin America(all income levels) to that in Latin America(developing only)?
Your answer should be compact. 0.66. What is the ratio of the ODA received (in %) of 1963 in Latin America(all income levels) to that in Latin America(developing only)?
Give a very brief answer. 0.73. What is the difference between the highest and the second highest ODA received (in %) in 1960?
Provide a short and direct response. 0.07. What is the difference between the highest and the second highest ODA received (in %) of 1961?
Give a very brief answer. 0.48. What is the difference between the highest and the second highest ODA received (in %) in 1962?
Give a very brief answer. 0.27. What is the difference between the highest and the second highest ODA received (in %) of 1963?
Give a very brief answer. 0.33. What is the difference between the highest and the lowest ODA received (in %) in 1960?
Provide a succinct answer. 0.63. What is the difference between the highest and the lowest ODA received (in %) in 1961?
Your answer should be compact. 1.27. What is the difference between the highest and the lowest ODA received (in %) in 1962?
Give a very brief answer. 1.12. What is the difference between the highest and the lowest ODA received (in %) in 1963?
Offer a terse response. 1.21. 